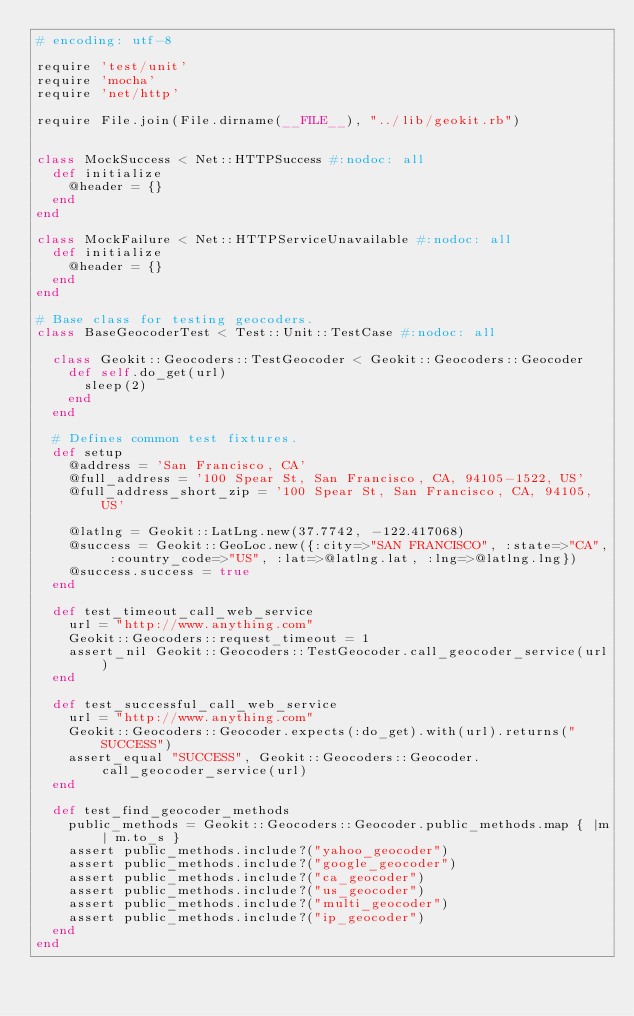Convert code to text. <code><loc_0><loc_0><loc_500><loc_500><_Ruby_># encoding: utf-8

require 'test/unit'
require 'mocha'
require 'net/http'

require File.join(File.dirname(__FILE__), "../lib/geokit.rb")


class MockSuccess < Net::HTTPSuccess #:nodoc: all
  def initialize
    @header = {}
  end
end

class MockFailure < Net::HTTPServiceUnavailable #:nodoc: all
  def initialize
    @header = {}
  end
end

# Base class for testing geocoders.
class BaseGeocoderTest < Test::Unit::TestCase #:nodoc: all

  class Geokit::Geocoders::TestGeocoder < Geokit::Geocoders::Geocoder
    def self.do_get(url)
      sleep(2)
    end
  end

  # Defines common test fixtures.
  def setup
    @address = 'San Francisco, CA'
    @full_address = '100 Spear St, San Francisco, CA, 94105-1522, US'
    @full_address_short_zip = '100 Spear St, San Francisco, CA, 94105, US'

    @latlng = Geokit::LatLng.new(37.7742, -122.417068)
    @success = Geokit::GeoLoc.new({:city=>"SAN FRANCISCO", :state=>"CA", :country_code=>"US", :lat=>@latlng.lat, :lng=>@latlng.lng})
    @success.success = true
  end

  def test_timeout_call_web_service
    url = "http://www.anything.com"
    Geokit::Geocoders::request_timeout = 1
    assert_nil Geokit::Geocoders::TestGeocoder.call_geocoder_service(url)
  end

  def test_successful_call_web_service
    url = "http://www.anything.com"
    Geokit::Geocoders::Geocoder.expects(:do_get).with(url).returns("SUCCESS")
    assert_equal "SUCCESS", Geokit::Geocoders::Geocoder.call_geocoder_service(url)
  end

  def test_find_geocoder_methods
    public_methods = Geokit::Geocoders::Geocoder.public_methods.map { |m| m.to_s }
    assert public_methods.include?("yahoo_geocoder")
    assert public_methods.include?("google_geocoder")
    assert public_methods.include?("ca_geocoder")
    assert public_methods.include?("us_geocoder")
    assert public_methods.include?("multi_geocoder")
    assert public_methods.include?("ip_geocoder")
  end
end
</code> 